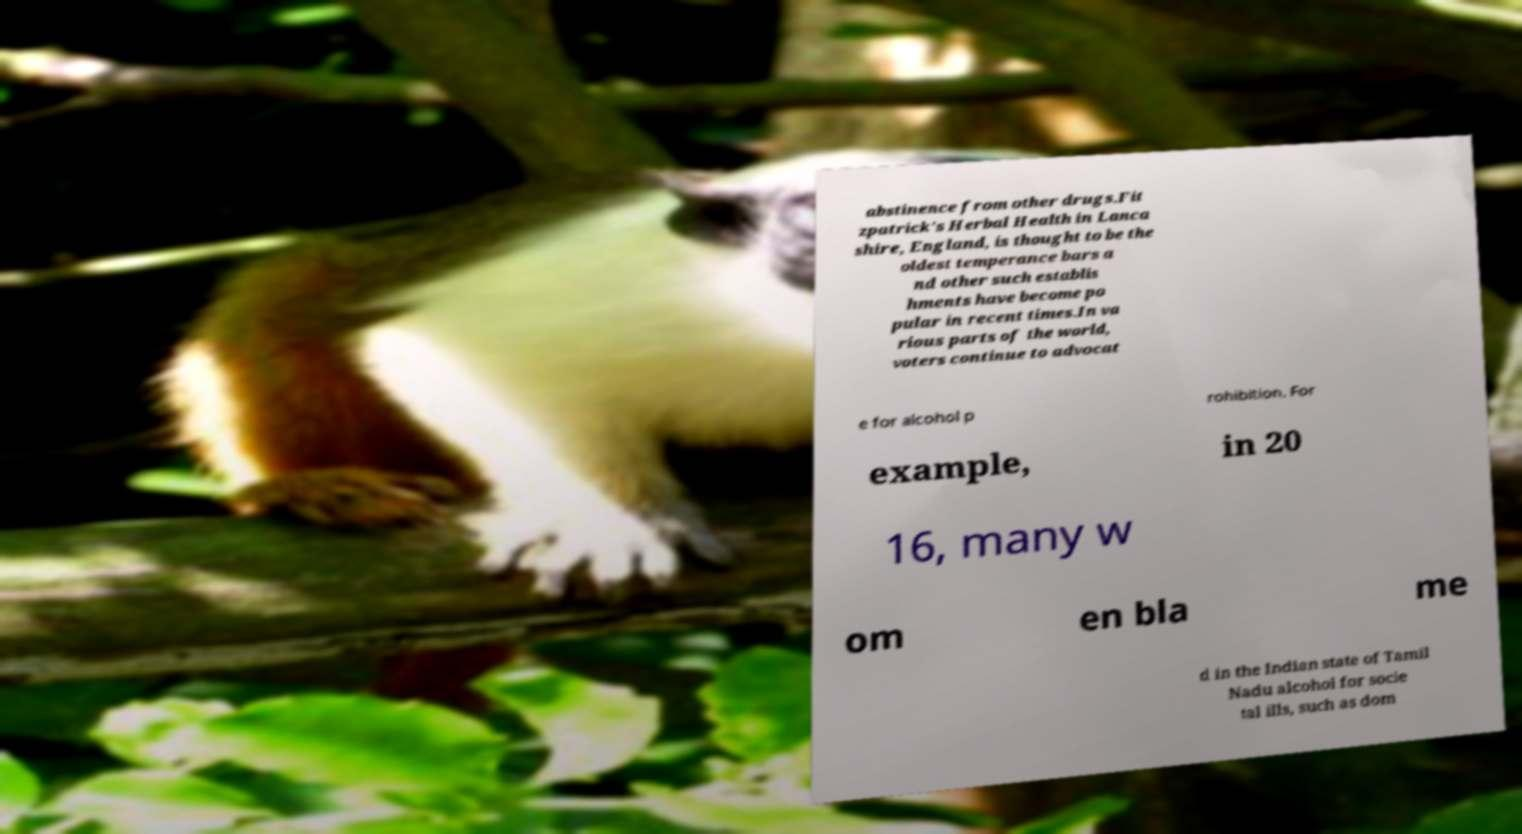I need the written content from this picture converted into text. Can you do that? abstinence from other drugs.Fit zpatrick's Herbal Health in Lanca shire, England, is thought to be the oldest temperance bars a nd other such establis hments have become po pular in recent times.In va rious parts of the world, voters continue to advocat e for alcohol p rohibition. For example, in 20 16, many w om en bla me d in the Indian state of Tamil Nadu alcohol for socie tal ills, such as dom 